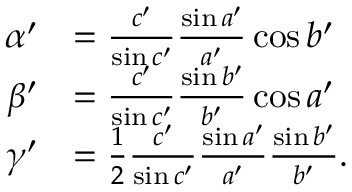Convert formula to latex. <formula><loc_0><loc_0><loc_500><loc_500>{ \begin{array} { r l } { \alpha ^ { \prime } } & { = { \frac { c ^ { \prime } } { \sin c ^ { \prime } } } { \frac { \sin a ^ { \prime } } { a ^ { \prime } } } \cos b ^ { \prime } } \\ { \beta ^ { \prime } } & { = { \frac { c ^ { \prime } } { \sin c ^ { \prime } } } { \frac { \sin b ^ { \prime } } { b ^ { \prime } } } \cos a ^ { \prime } } \\ { \gamma ^ { \prime } } & { = { \frac { 1 } { 2 } } { \frac { c ^ { \prime } } { \sin c ^ { \prime } } } { \frac { \sin a ^ { \prime } } { a ^ { \prime } } } { \frac { \sin b ^ { \prime } } { b ^ { \prime } } } . } \end{array} }</formula> 